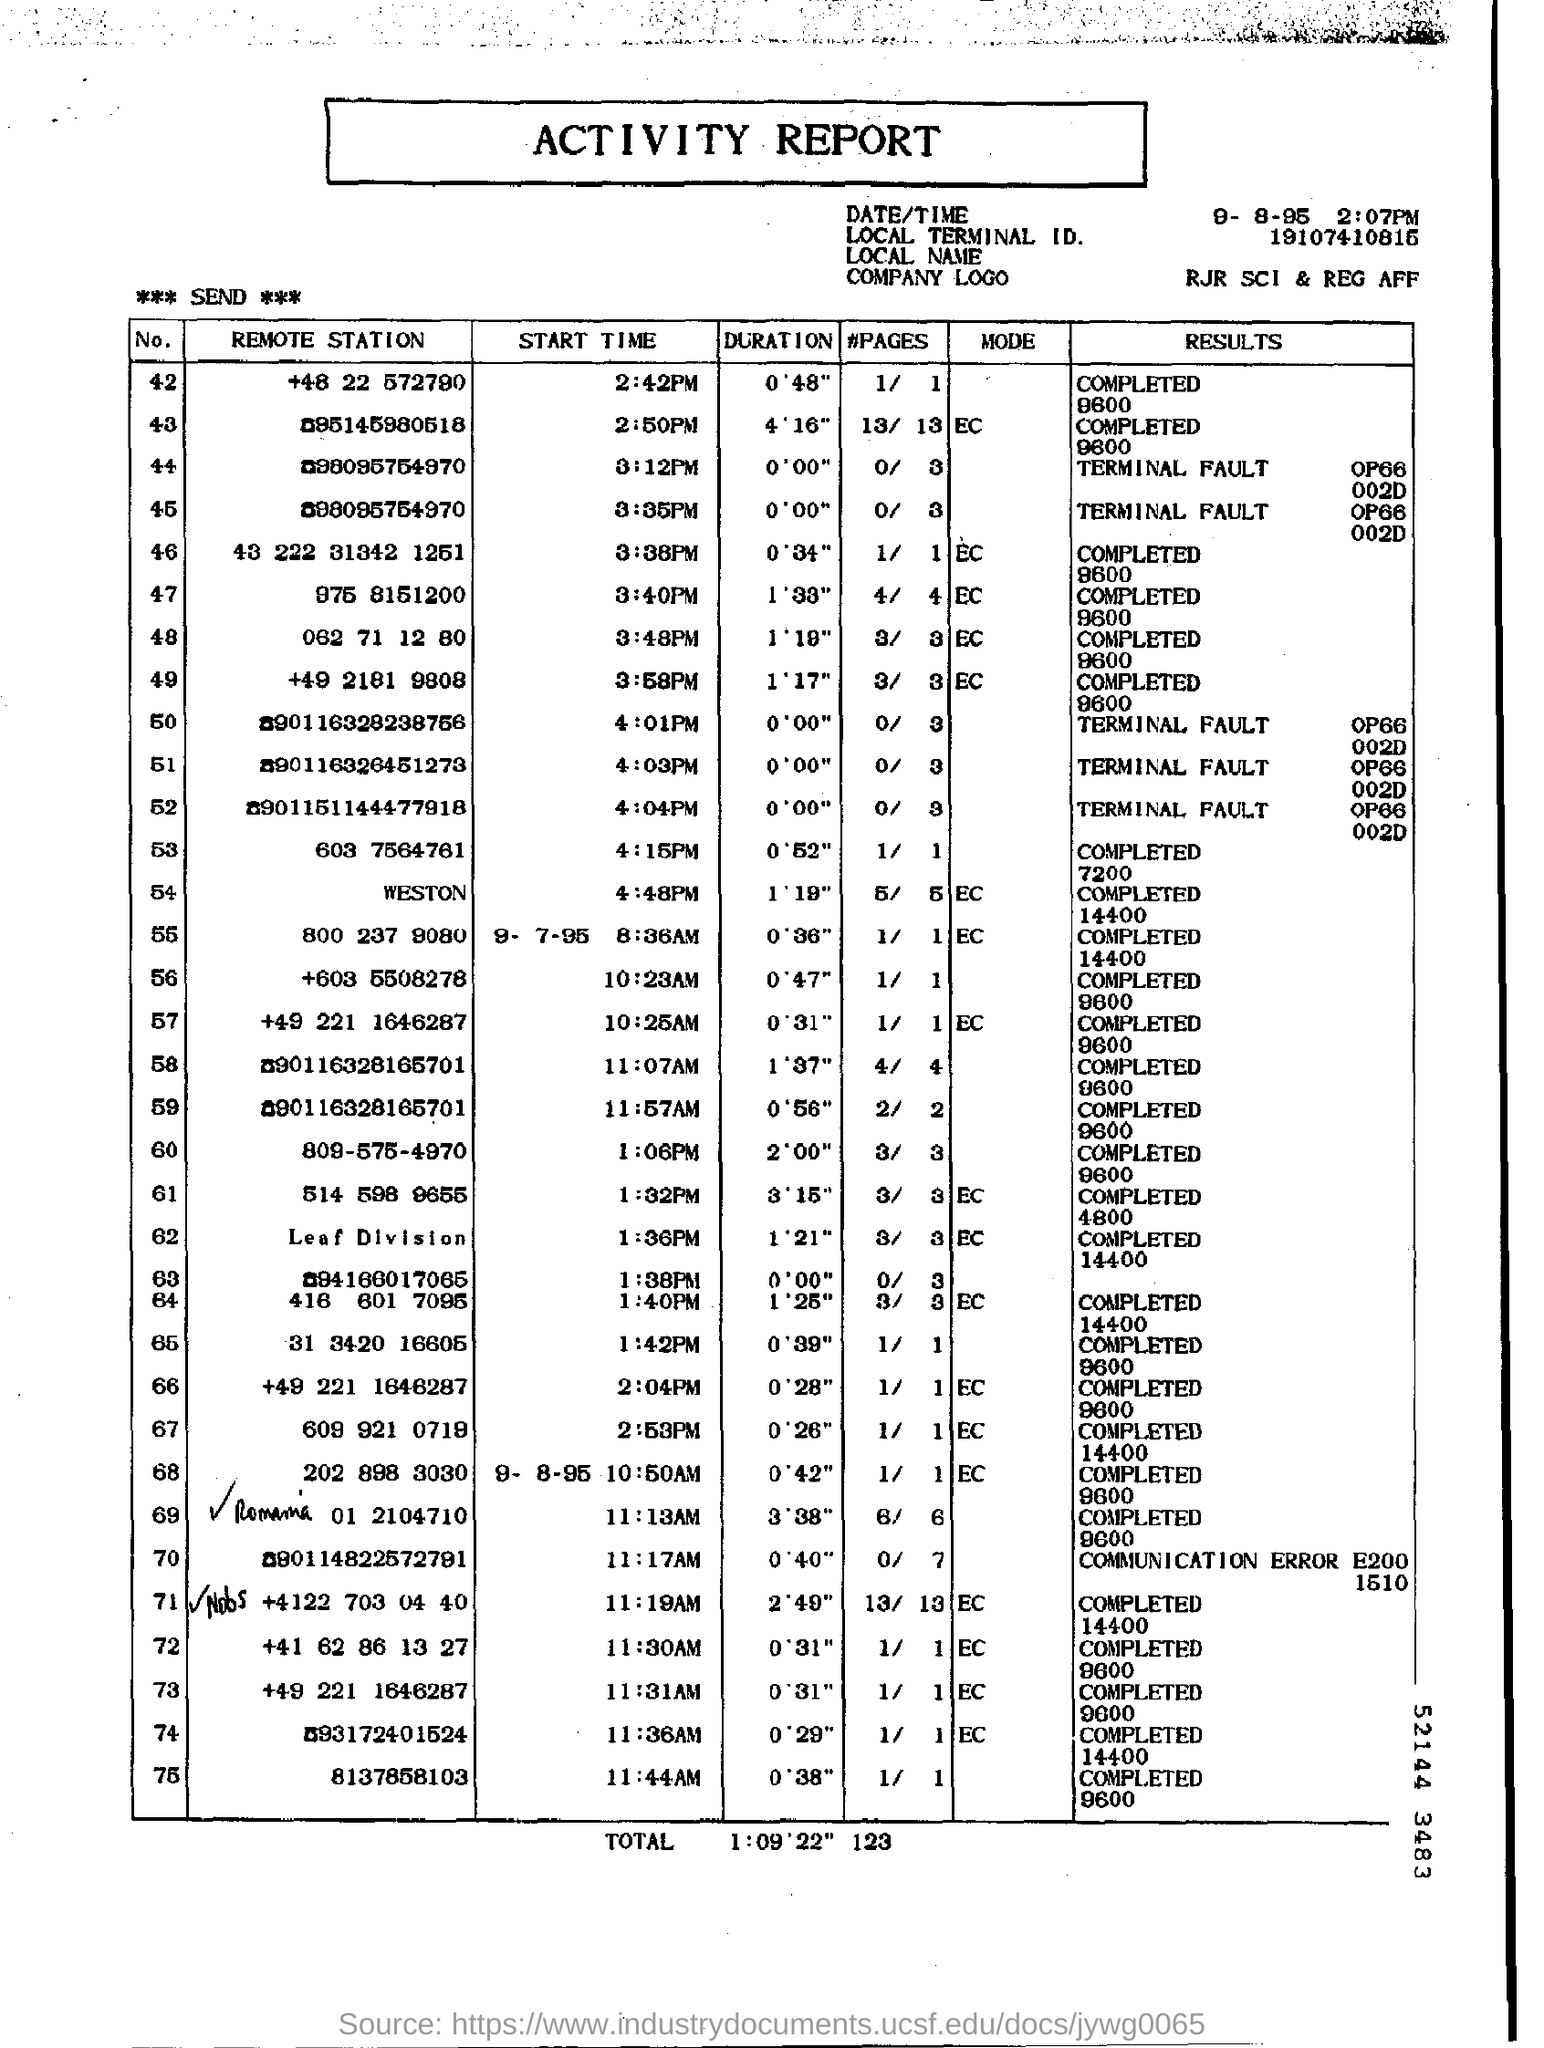What is the name of the report ?
Keep it short and to the point. Activity report. 